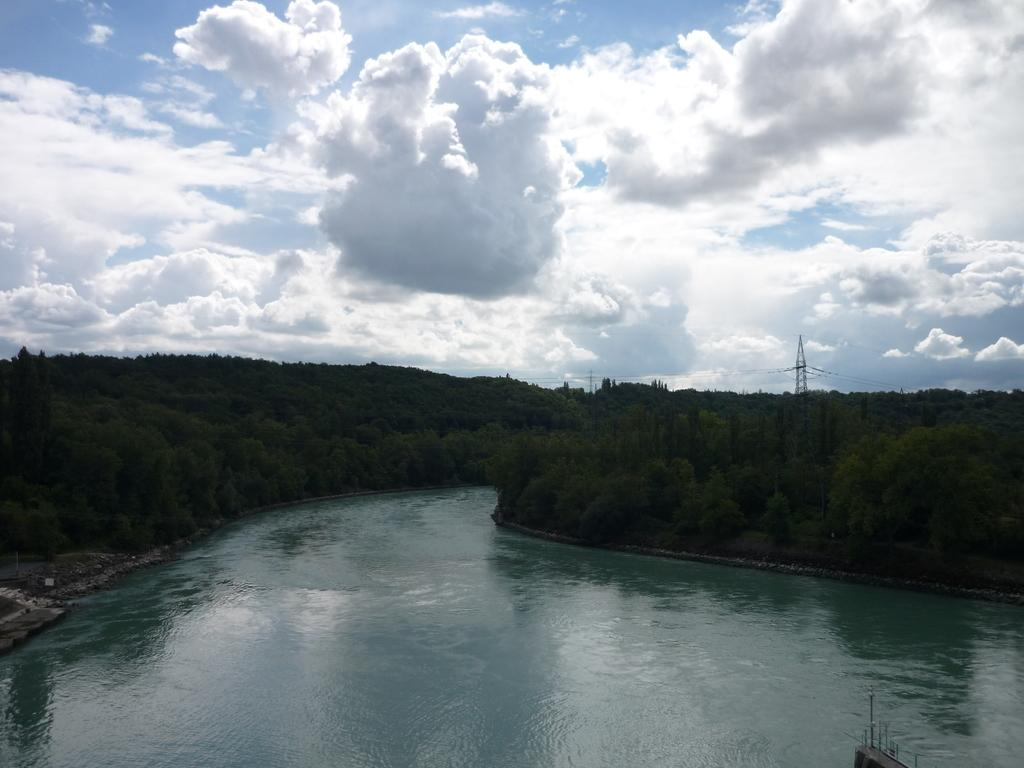What is in the foreground of the image? There is water in the foreground of the image. What can be seen in the middle of the image? There are many trees in the middle of the image. What is visible in the background of the image? The sky is visible in the background of the image. Can you see any ears on the trees in the image? There are no ears present on the trees in the image, as trees do not have ears. Are there any boots visible in the water in the foreground of the image? There are no boots visible in the water in the foreground of the image. 